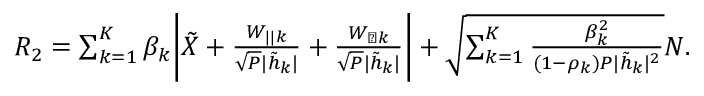Convert formula to latex. <formula><loc_0><loc_0><loc_500><loc_500>\begin{array} { r } { { { R } _ { 2 } } = \sum _ { k = 1 } ^ { K } \beta _ { k } \left | { { \tilde { X } } } + \frac { { { { W } _ { | | k } } } } { \sqrt { P } { | \tilde { h } _ { k } | } } + \frac { { { { W } _ { \perp k } } } } { \sqrt { P } { | \tilde { h } _ { k } | } } \right | + \sqrt { \sum _ { k = 1 } ^ { K } \frac { \beta _ { k } ^ { 2 } } { ( 1 - \rho _ { k } ) P | \tilde { h } _ { k } | ^ { 2 } } } { N } . } \end{array}</formula> 